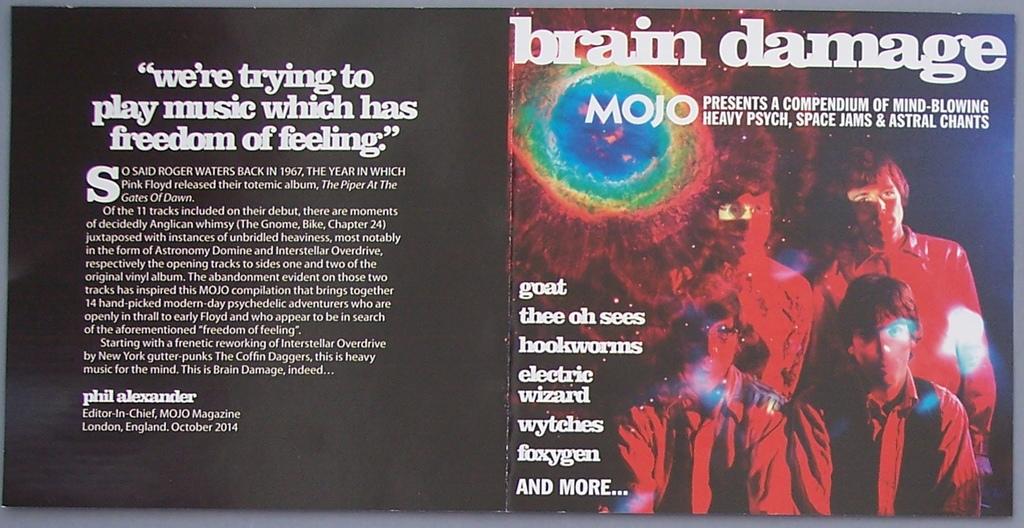What kind of music are they trying to play?
Keep it short and to the point. Freedom of feeling. Who is quoted on the left side?
Your answer should be compact. Phil alexander. 